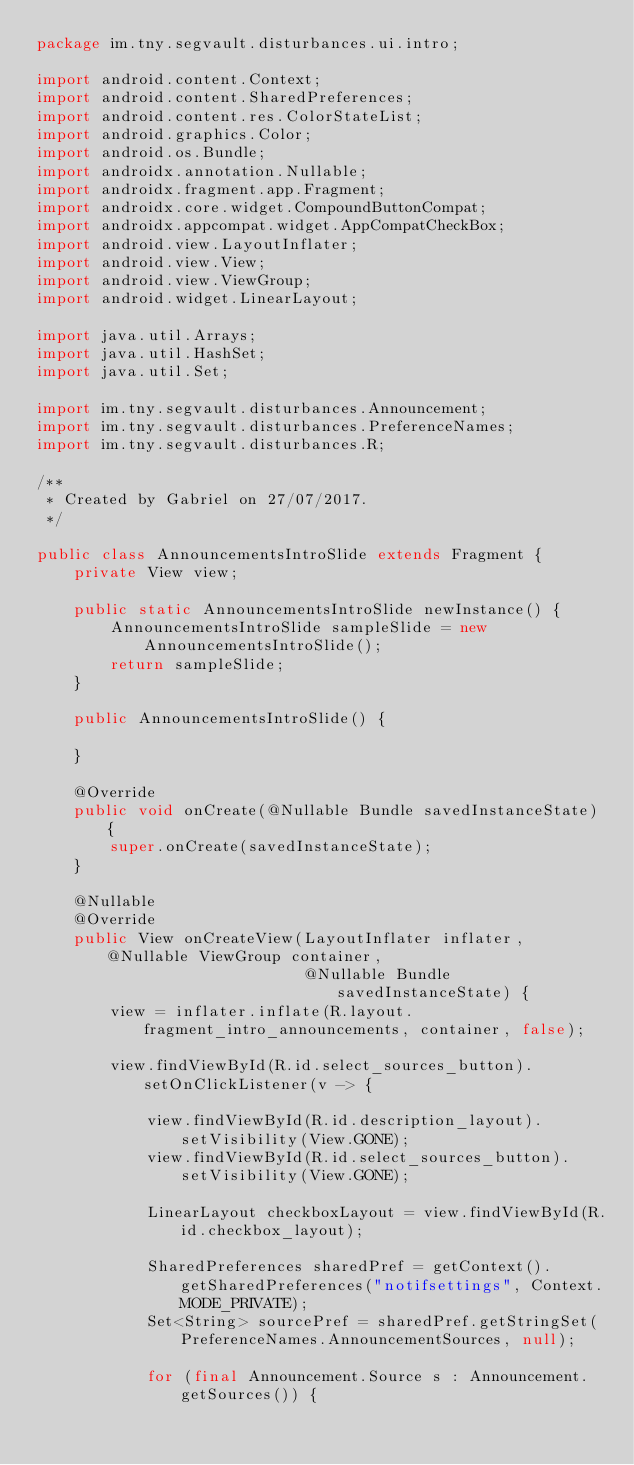<code> <loc_0><loc_0><loc_500><loc_500><_Java_>package im.tny.segvault.disturbances.ui.intro;

import android.content.Context;
import android.content.SharedPreferences;
import android.content.res.ColorStateList;
import android.graphics.Color;
import android.os.Bundle;
import androidx.annotation.Nullable;
import androidx.fragment.app.Fragment;
import androidx.core.widget.CompoundButtonCompat;
import androidx.appcompat.widget.AppCompatCheckBox;
import android.view.LayoutInflater;
import android.view.View;
import android.view.ViewGroup;
import android.widget.LinearLayout;

import java.util.Arrays;
import java.util.HashSet;
import java.util.Set;

import im.tny.segvault.disturbances.Announcement;
import im.tny.segvault.disturbances.PreferenceNames;
import im.tny.segvault.disturbances.R;

/**
 * Created by Gabriel on 27/07/2017.
 */

public class AnnouncementsIntroSlide extends Fragment {
    private View view;

    public static AnnouncementsIntroSlide newInstance() {
        AnnouncementsIntroSlide sampleSlide = new AnnouncementsIntroSlide();
        return sampleSlide;
    }

    public AnnouncementsIntroSlide() {

    }

    @Override
    public void onCreate(@Nullable Bundle savedInstanceState) {
        super.onCreate(savedInstanceState);
    }

    @Nullable
    @Override
    public View onCreateView(LayoutInflater inflater, @Nullable ViewGroup container,
                             @Nullable Bundle savedInstanceState) {
        view = inflater.inflate(R.layout.fragment_intro_announcements, container, false);

        view.findViewById(R.id.select_sources_button).setOnClickListener(v -> {

            view.findViewById(R.id.description_layout).setVisibility(View.GONE);
            view.findViewById(R.id.select_sources_button).setVisibility(View.GONE);

            LinearLayout checkboxLayout = view.findViewById(R.id.checkbox_layout);

            SharedPreferences sharedPref = getContext().getSharedPreferences("notifsettings", Context.MODE_PRIVATE);
            Set<String> sourcePref = sharedPref.getStringSet(PreferenceNames.AnnouncementSources, null);

            for (final Announcement.Source s : Announcement.getSources()) {</code> 